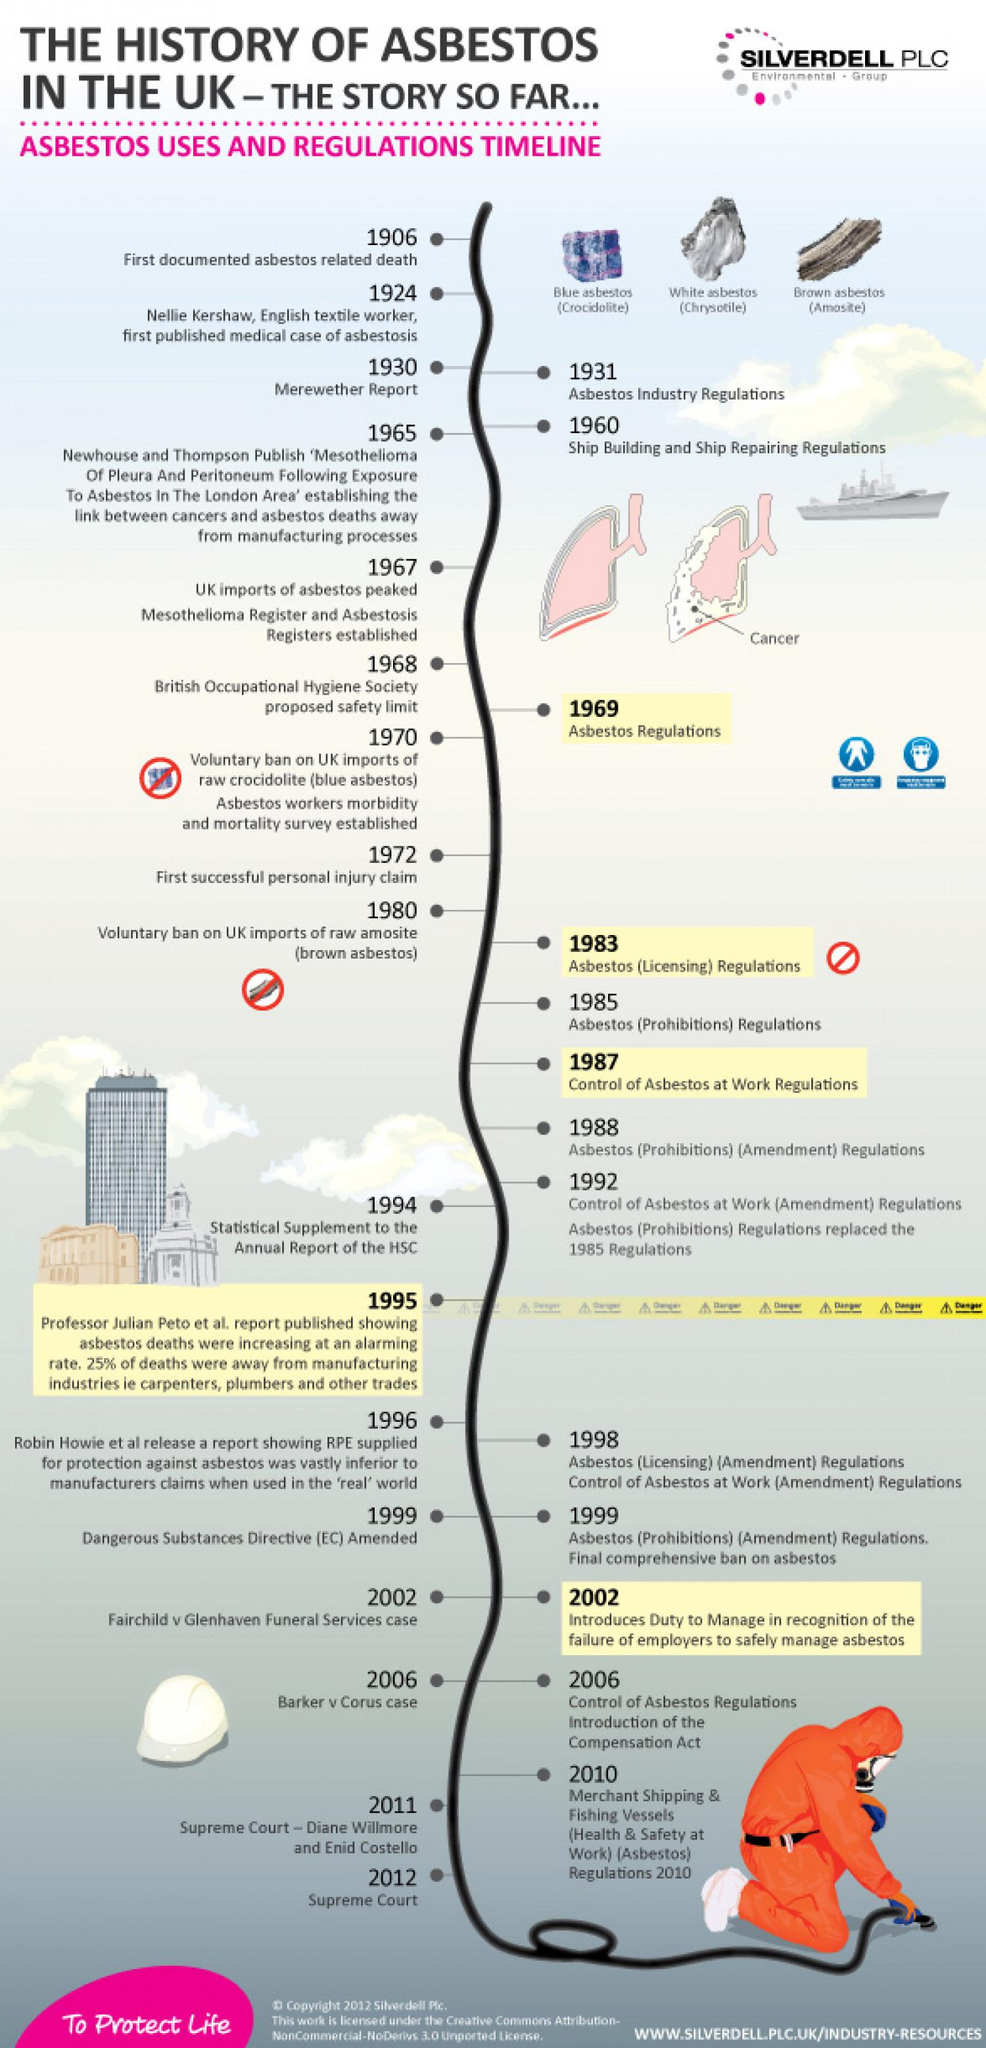Identify some key points in this picture. There are three types of asbestos that are shown. Chrysotile, commonly known as white asbestos, is a mineral fiber that is recognized by its white color and long, thin crystal structure. The Asbestos Workers Morbidity and Mortality Survey was established in 1970. The scientific name for blue asbestos is crocidolite. The Merewether Report was published in 1930. 